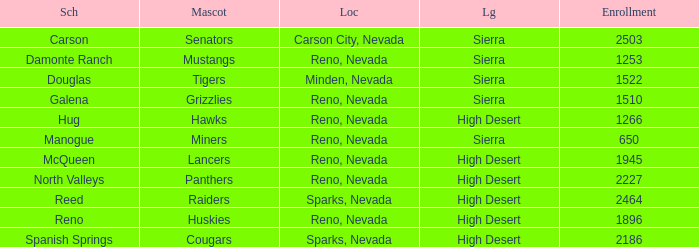Write the full table. {'header': ['Sch', 'Mascot', 'Loc', 'Lg', 'Enrollment'], 'rows': [['Carson', 'Senators', 'Carson City, Nevada', 'Sierra', '2503'], ['Damonte Ranch', 'Mustangs', 'Reno, Nevada', 'Sierra', '1253'], ['Douglas', 'Tigers', 'Minden, Nevada', 'Sierra', '1522'], ['Galena', 'Grizzlies', 'Reno, Nevada', 'Sierra', '1510'], ['Hug', 'Hawks', 'Reno, Nevada', 'High Desert', '1266'], ['Manogue', 'Miners', 'Reno, Nevada', 'Sierra', '650'], ['McQueen', 'Lancers', 'Reno, Nevada', 'High Desert', '1945'], ['North Valleys', 'Panthers', 'Reno, Nevada', 'High Desert', '2227'], ['Reed', 'Raiders', 'Sparks, Nevada', 'High Desert', '2464'], ['Reno', 'Huskies', 'Reno, Nevada', 'High Desert', '1896'], ['Spanish Springs', 'Cougars', 'Sparks, Nevada', 'High Desert', '2186']]} Which leagues have Raiders as their mascot? High Desert. 